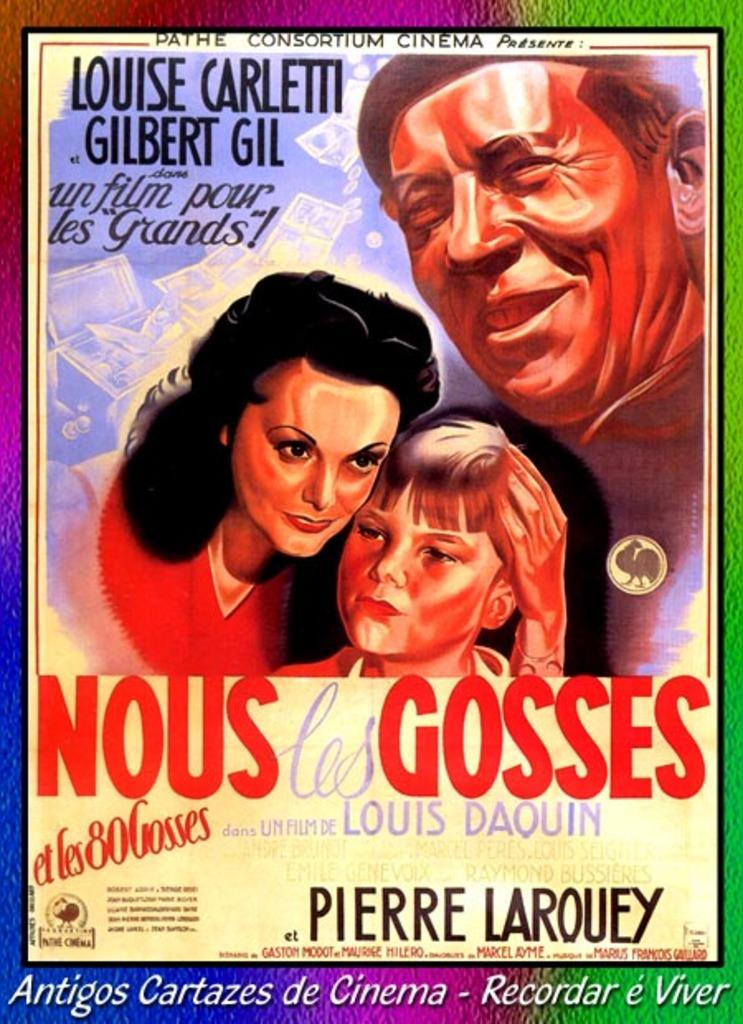What is the main subject of the image? The main subject of the image is a graphical image of three persons. Can you describe the relationship between the persons in the image? One woman is holding a boy with her hand. What type of mailbox can be seen in the image? There is no mailbox present in the image; it features a graphical image of three persons. Can you tell me how many bulbs are visible in the image? There are no bulbs visible in the image; it features a graphical image of three persons. 